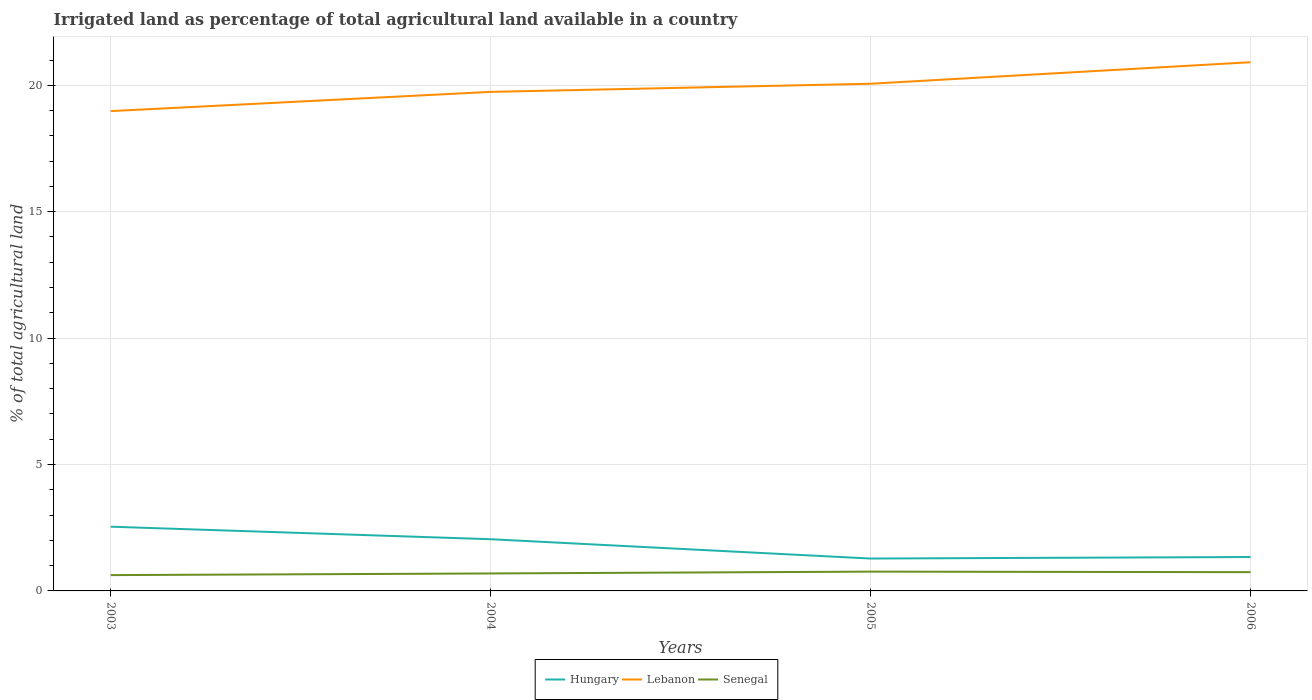How many different coloured lines are there?
Provide a succinct answer. 3. Is the number of lines equal to the number of legend labels?
Your response must be concise. Yes. Across all years, what is the maximum percentage of irrigated land in Senegal?
Make the answer very short. 0.63. What is the total percentage of irrigated land in Hungary in the graph?
Offer a terse response. 0.5. What is the difference between the highest and the second highest percentage of irrigated land in Senegal?
Your response must be concise. 0.14. What is the difference between the highest and the lowest percentage of irrigated land in Senegal?
Provide a short and direct response. 2. Is the percentage of irrigated land in Senegal strictly greater than the percentage of irrigated land in Hungary over the years?
Make the answer very short. Yes. How many lines are there?
Offer a terse response. 3. Does the graph contain grids?
Your response must be concise. Yes. Where does the legend appear in the graph?
Provide a short and direct response. Bottom center. How are the legend labels stacked?
Your answer should be very brief. Horizontal. What is the title of the graph?
Your answer should be compact. Irrigated land as percentage of total agricultural land available in a country. Does "Peru" appear as one of the legend labels in the graph?
Make the answer very short. No. What is the label or title of the X-axis?
Your response must be concise. Years. What is the label or title of the Y-axis?
Provide a short and direct response. % of total agricultural land. What is the % of total agricultural land in Hungary in 2003?
Your answer should be very brief. 2.54. What is the % of total agricultural land of Lebanon in 2003?
Your answer should be very brief. 18.98. What is the % of total agricultural land of Senegal in 2003?
Your answer should be compact. 0.63. What is the % of total agricultural land in Hungary in 2004?
Offer a very short reply. 2.05. What is the % of total agricultural land in Lebanon in 2004?
Your response must be concise. 19.74. What is the % of total agricultural land in Senegal in 2004?
Your answer should be very brief. 0.69. What is the % of total agricultural land in Hungary in 2005?
Give a very brief answer. 1.28. What is the % of total agricultural land of Lebanon in 2005?
Your answer should be very brief. 20.06. What is the % of total agricultural land of Senegal in 2005?
Your response must be concise. 0.76. What is the % of total agricultural land in Hungary in 2006?
Your response must be concise. 1.34. What is the % of total agricultural land in Lebanon in 2006?
Provide a short and direct response. 20.91. What is the % of total agricultural land of Senegal in 2006?
Offer a very short reply. 0.74. Across all years, what is the maximum % of total agricultural land of Hungary?
Give a very brief answer. 2.54. Across all years, what is the maximum % of total agricultural land of Lebanon?
Make the answer very short. 20.91. Across all years, what is the maximum % of total agricultural land in Senegal?
Your response must be concise. 0.76. Across all years, what is the minimum % of total agricultural land in Hungary?
Provide a short and direct response. 1.28. Across all years, what is the minimum % of total agricultural land of Lebanon?
Give a very brief answer. 18.98. Across all years, what is the minimum % of total agricultural land in Senegal?
Provide a succinct answer. 0.63. What is the total % of total agricultural land of Hungary in the graph?
Offer a very short reply. 7.21. What is the total % of total agricultural land of Lebanon in the graph?
Keep it short and to the point. 79.69. What is the total % of total agricultural land in Senegal in the graph?
Offer a terse response. 2.82. What is the difference between the % of total agricultural land in Hungary in 2003 and that in 2004?
Make the answer very short. 0.5. What is the difference between the % of total agricultural land of Lebanon in 2003 and that in 2004?
Your answer should be compact. -0.76. What is the difference between the % of total agricultural land in Senegal in 2003 and that in 2004?
Offer a very short reply. -0.07. What is the difference between the % of total agricultural land in Hungary in 2003 and that in 2005?
Give a very brief answer. 1.26. What is the difference between the % of total agricultural land in Lebanon in 2003 and that in 2005?
Ensure brevity in your answer.  -1.08. What is the difference between the % of total agricultural land of Senegal in 2003 and that in 2005?
Your response must be concise. -0.14. What is the difference between the % of total agricultural land in Hungary in 2003 and that in 2006?
Make the answer very short. 1.2. What is the difference between the % of total agricultural land of Lebanon in 2003 and that in 2006?
Your answer should be compact. -1.93. What is the difference between the % of total agricultural land of Senegal in 2003 and that in 2006?
Make the answer very short. -0.12. What is the difference between the % of total agricultural land of Hungary in 2004 and that in 2005?
Give a very brief answer. 0.76. What is the difference between the % of total agricultural land of Lebanon in 2004 and that in 2005?
Make the answer very short. -0.32. What is the difference between the % of total agricultural land of Senegal in 2004 and that in 2005?
Provide a short and direct response. -0.07. What is the difference between the % of total agricultural land of Hungary in 2004 and that in 2006?
Make the answer very short. 0.7. What is the difference between the % of total agricultural land of Lebanon in 2004 and that in 2006?
Your response must be concise. -1.17. What is the difference between the % of total agricultural land in Senegal in 2004 and that in 2006?
Offer a very short reply. -0.05. What is the difference between the % of total agricultural land of Hungary in 2005 and that in 2006?
Provide a short and direct response. -0.06. What is the difference between the % of total agricultural land of Lebanon in 2005 and that in 2006?
Your response must be concise. -0.85. What is the difference between the % of total agricultural land in Senegal in 2005 and that in 2006?
Keep it short and to the point. 0.02. What is the difference between the % of total agricultural land of Hungary in 2003 and the % of total agricultural land of Lebanon in 2004?
Your response must be concise. -17.2. What is the difference between the % of total agricultural land in Hungary in 2003 and the % of total agricultural land in Senegal in 2004?
Provide a succinct answer. 1.85. What is the difference between the % of total agricultural land of Lebanon in 2003 and the % of total agricultural land of Senegal in 2004?
Give a very brief answer. 18.29. What is the difference between the % of total agricultural land of Hungary in 2003 and the % of total agricultural land of Lebanon in 2005?
Make the answer very short. -17.52. What is the difference between the % of total agricultural land in Hungary in 2003 and the % of total agricultural land in Senegal in 2005?
Give a very brief answer. 1.78. What is the difference between the % of total agricultural land of Lebanon in 2003 and the % of total agricultural land of Senegal in 2005?
Give a very brief answer. 18.22. What is the difference between the % of total agricultural land of Hungary in 2003 and the % of total agricultural land of Lebanon in 2006?
Ensure brevity in your answer.  -18.37. What is the difference between the % of total agricultural land in Hungary in 2003 and the % of total agricultural land in Senegal in 2006?
Ensure brevity in your answer.  1.8. What is the difference between the % of total agricultural land in Lebanon in 2003 and the % of total agricultural land in Senegal in 2006?
Offer a terse response. 18.24. What is the difference between the % of total agricultural land of Hungary in 2004 and the % of total agricultural land of Lebanon in 2005?
Provide a short and direct response. -18.02. What is the difference between the % of total agricultural land in Hungary in 2004 and the % of total agricultural land in Senegal in 2005?
Make the answer very short. 1.28. What is the difference between the % of total agricultural land in Lebanon in 2004 and the % of total agricultural land in Senegal in 2005?
Ensure brevity in your answer.  18.98. What is the difference between the % of total agricultural land in Hungary in 2004 and the % of total agricultural land in Lebanon in 2006?
Ensure brevity in your answer.  -18.87. What is the difference between the % of total agricultural land in Hungary in 2004 and the % of total agricultural land in Senegal in 2006?
Make the answer very short. 1.3. What is the difference between the % of total agricultural land of Lebanon in 2004 and the % of total agricultural land of Senegal in 2006?
Provide a short and direct response. 19. What is the difference between the % of total agricultural land in Hungary in 2005 and the % of total agricultural land in Lebanon in 2006?
Ensure brevity in your answer.  -19.63. What is the difference between the % of total agricultural land in Hungary in 2005 and the % of total agricultural land in Senegal in 2006?
Your answer should be very brief. 0.54. What is the difference between the % of total agricultural land of Lebanon in 2005 and the % of total agricultural land of Senegal in 2006?
Give a very brief answer. 19.32. What is the average % of total agricultural land in Hungary per year?
Provide a short and direct response. 1.8. What is the average % of total agricultural land of Lebanon per year?
Make the answer very short. 19.92. What is the average % of total agricultural land in Senegal per year?
Offer a terse response. 0.71. In the year 2003, what is the difference between the % of total agricultural land of Hungary and % of total agricultural land of Lebanon?
Your answer should be very brief. -16.44. In the year 2003, what is the difference between the % of total agricultural land in Hungary and % of total agricultural land in Senegal?
Ensure brevity in your answer.  1.91. In the year 2003, what is the difference between the % of total agricultural land in Lebanon and % of total agricultural land in Senegal?
Keep it short and to the point. 18.35. In the year 2004, what is the difference between the % of total agricultural land of Hungary and % of total agricultural land of Lebanon?
Offer a terse response. -17.69. In the year 2004, what is the difference between the % of total agricultural land in Hungary and % of total agricultural land in Senegal?
Keep it short and to the point. 1.35. In the year 2004, what is the difference between the % of total agricultural land of Lebanon and % of total agricultural land of Senegal?
Make the answer very short. 19.05. In the year 2005, what is the difference between the % of total agricultural land of Hungary and % of total agricultural land of Lebanon?
Your response must be concise. -18.78. In the year 2005, what is the difference between the % of total agricultural land of Hungary and % of total agricultural land of Senegal?
Provide a short and direct response. 0.52. In the year 2005, what is the difference between the % of total agricultural land in Lebanon and % of total agricultural land in Senegal?
Offer a very short reply. 19.3. In the year 2006, what is the difference between the % of total agricultural land of Hungary and % of total agricultural land of Lebanon?
Offer a very short reply. -19.57. In the year 2006, what is the difference between the % of total agricultural land in Hungary and % of total agricultural land in Senegal?
Your answer should be compact. 0.6. In the year 2006, what is the difference between the % of total agricultural land of Lebanon and % of total agricultural land of Senegal?
Your answer should be compact. 20.17. What is the ratio of the % of total agricultural land of Hungary in 2003 to that in 2004?
Offer a terse response. 1.24. What is the ratio of the % of total agricultural land of Lebanon in 2003 to that in 2004?
Your answer should be compact. 0.96. What is the ratio of the % of total agricultural land in Senegal in 2003 to that in 2004?
Your answer should be very brief. 0.91. What is the ratio of the % of total agricultural land of Hungary in 2003 to that in 2005?
Ensure brevity in your answer.  1.98. What is the ratio of the % of total agricultural land of Lebanon in 2003 to that in 2005?
Provide a short and direct response. 0.95. What is the ratio of the % of total agricultural land in Senegal in 2003 to that in 2005?
Your answer should be very brief. 0.82. What is the ratio of the % of total agricultural land of Hungary in 2003 to that in 2006?
Make the answer very short. 1.89. What is the ratio of the % of total agricultural land of Lebanon in 2003 to that in 2006?
Your response must be concise. 0.91. What is the ratio of the % of total agricultural land of Senegal in 2003 to that in 2006?
Offer a very short reply. 0.84. What is the ratio of the % of total agricultural land in Hungary in 2004 to that in 2005?
Give a very brief answer. 1.6. What is the ratio of the % of total agricultural land in Senegal in 2004 to that in 2005?
Keep it short and to the point. 0.9. What is the ratio of the % of total agricultural land in Hungary in 2004 to that in 2006?
Provide a short and direct response. 1.52. What is the ratio of the % of total agricultural land of Lebanon in 2004 to that in 2006?
Provide a succinct answer. 0.94. What is the ratio of the % of total agricultural land in Senegal in 2004 to that in 2006?
Your answer should be very brief. 0.93. What is the ratio of the % of total agricultural land of Hungary in 2005 to that in 2006?
Keep it short and to the point. 0.95. What is the ratio of the % of total agricultural land of Lebanon in 2005 to that in 2006?
Your answer should be compact. 0.96. What is the ratio of the % of total agricultural land in Senegal in 2005 to that in 2006?
Your response must be concise. 1.03. What is the difference between the highest and the second highest % of total agricultural land in Hungary?
Make the answer very short. 0.5. What is the difference between the highest and the second highest % of total agricultural land in Lebanon?
Make the answer very short. 0.85. What is the difference between the highest and the second highest % of total agricultural land in Senegal?
Your answer should be compact. 0.02. What is the difference between the highest and the lowest % of total agricultural land in Hungary?
Your answer should be very brief. 1.26. What is the difference between the highest and the lowest % of total agricultural land of Lebanon?
Make the answer very short. 1.93. What is the difference between the highest and the lowest % of total agricultural land in Senegal?
Ensure brevity in your answer.  0.14. 